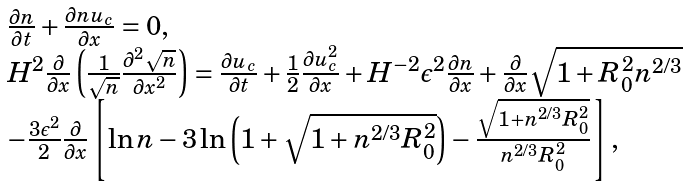<formula> <loc_0><loc_0><loc_500><loc_500>\begin{array} { l } \frac { \partial n } { \partial t } + \frac { { \partial n { u _ { c } } } } { \partial x } = 0 , \\ { H ^ { 2 } } \frac { \partial } { \partial x } \left ( { \frac { 1 } { \sqrt { n } } \frac { { { \partial ^ { 2 } } \sqrt { n } } } { { \partial { x ^ { 2 } } } } } \right ) = \frac { { \partial { u _ { c } } } } { \partial t } + \frac { 1 } { 2 } \frac { \partial u _ { c } ^ { 2 } } { \partial x } + { H ^ { - 2 } } { \epsilon ^ { 2 } } \frac { \partial n } { \partial x } + \frac { \partial } { \partial x } \sqrt { 1 + R _ { 0 } ^ { 2 } { n ^ { 2 / 3 } } } \\ - \frac { { 3 { \epsilon ^ { 2 } } } } { 2 } \frac { \partial } { \partial x } \left [ { \ln n - 3 \ln \left ( { 1 + \sqrt { 1 + { n ^ { 2 / 3 } } R _ { 0 } ^ { 2 } } } \right ) - \frac { { \sqrt { 1 + { n ^ { 2 / 3 } } R _ { 0 } ^ { 2 } } } } { { { n ^ { 2 / 3 } } R _ { 0 } ^ { 2 } } } } \right ] , \\ \end{array}</formula> 